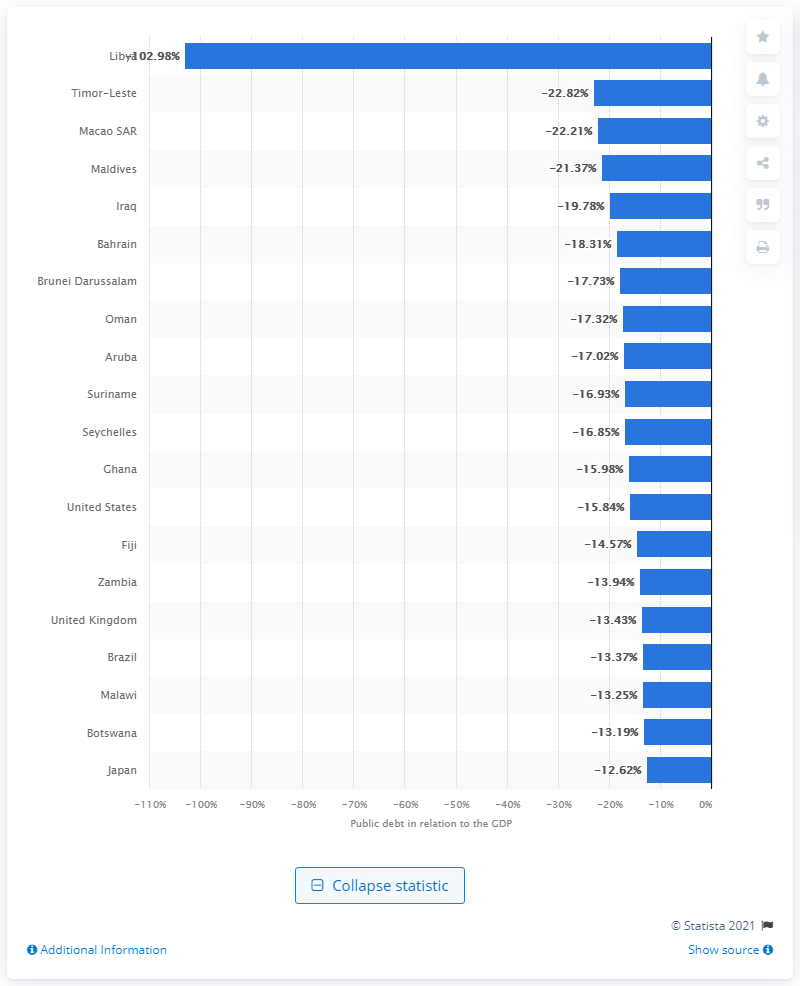Highlight a few significant elements in this photo. According to the latest data, Libya was the country with the highest public debt levels among all countries in 2020. 